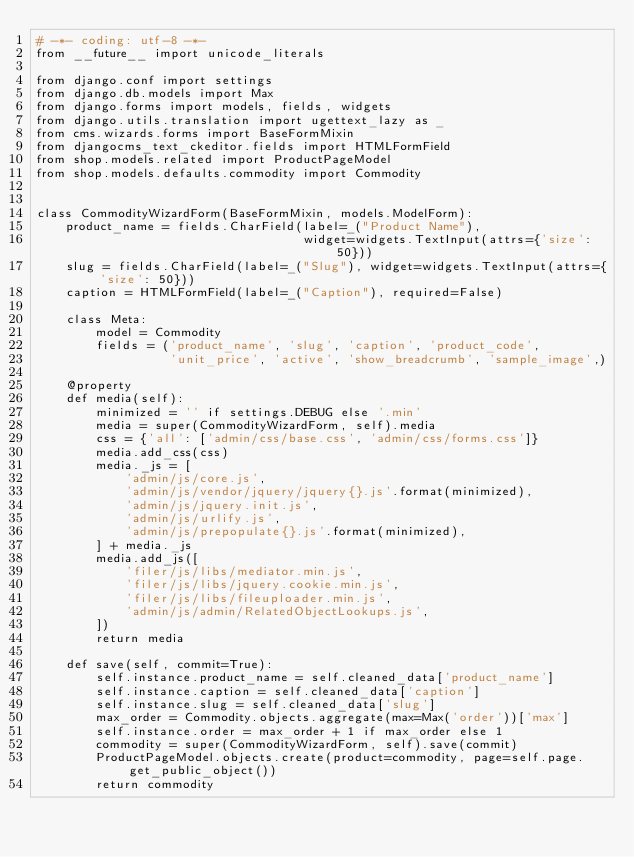<code> <loc_0><loc_0><loc_500><loc_500><_Python_># -*- coding: utf-8 -*-
from __future__ import unicode_literals

from django.conf import settings
from django.db.models import Max
from django.forms import models, fields, widgets
from django.utils.translation import ugettext_lazy as _
from cms.wizards.forms import BaseFormMixin
from djangocms_text_ckeditor.fields import HTMLFormField
from shop.models.related import ProductPageModel
from shop.models.defaults.commodity import Commodity


class CommodityWizardForm(BaseFormMixin, models.ModelForm):
    product_name = fields.CharField(label=_("Product Name"),
                                    widget=widgets.TextInput(attrs={'size': 50}))
    slug = fields.CharField(label=_("Slug"), widget=widgets.TextInput(attrs={'size': 50}))
    caption = HTMLFormField(label=_("Caption"), required=False)

    class Meta:
        model = Commodity
        fields = ('product_name', 'slug', 'caption', 'product_code',
                  'unit_price', 'active', 'show_breadcrumb', 'sample_image',)

    @property
    def media(self):
        minimized = '' if settings.DEBUG else '.min'
        media = super(CommodityWizardForm, self).media
        css = {'all': ['admin/css/base.css', 'admin/css/forms.css']}
        media.add_css(css)
        media._js = [
            'admin/js/core.js',
            'admin/js/vendor/jquery/jquery{}.js'.format(minimized),
            'admin/js/jquery.init.js',
            'admin/js/urlify.js',
            'admin/js/prepopulate{}.js'.format(minimized),
        ] + media._js
        media.add_js([
            'filer/js/libs/mediator.min.js',
            'filer/js/libs/jquery.cookie.min.js',
            'filer/js/libs/fileuploader.min.js',
            'admin/js/admin/RelatedObjectLookups.js',
        ])
        return media

    def save(self, commit=True):
        self.instance.product_name = self.cleaned_data['product_name']
        self.instance.caption = self.cleaned_data['caption']
        self.instance.slug = self.cleaned_data['slug']
        max_order = Commodity.objects.aggregate(max=Max('order'))['max']
        self.instance.order = max_order + 1 if max_order else 1
        commodity = super(CommodityWizardForm, self).save(commit)
        ProductPageModel.objects.create(product=commodity, page=self.page.get_public_object())
        return commodity
</code> 